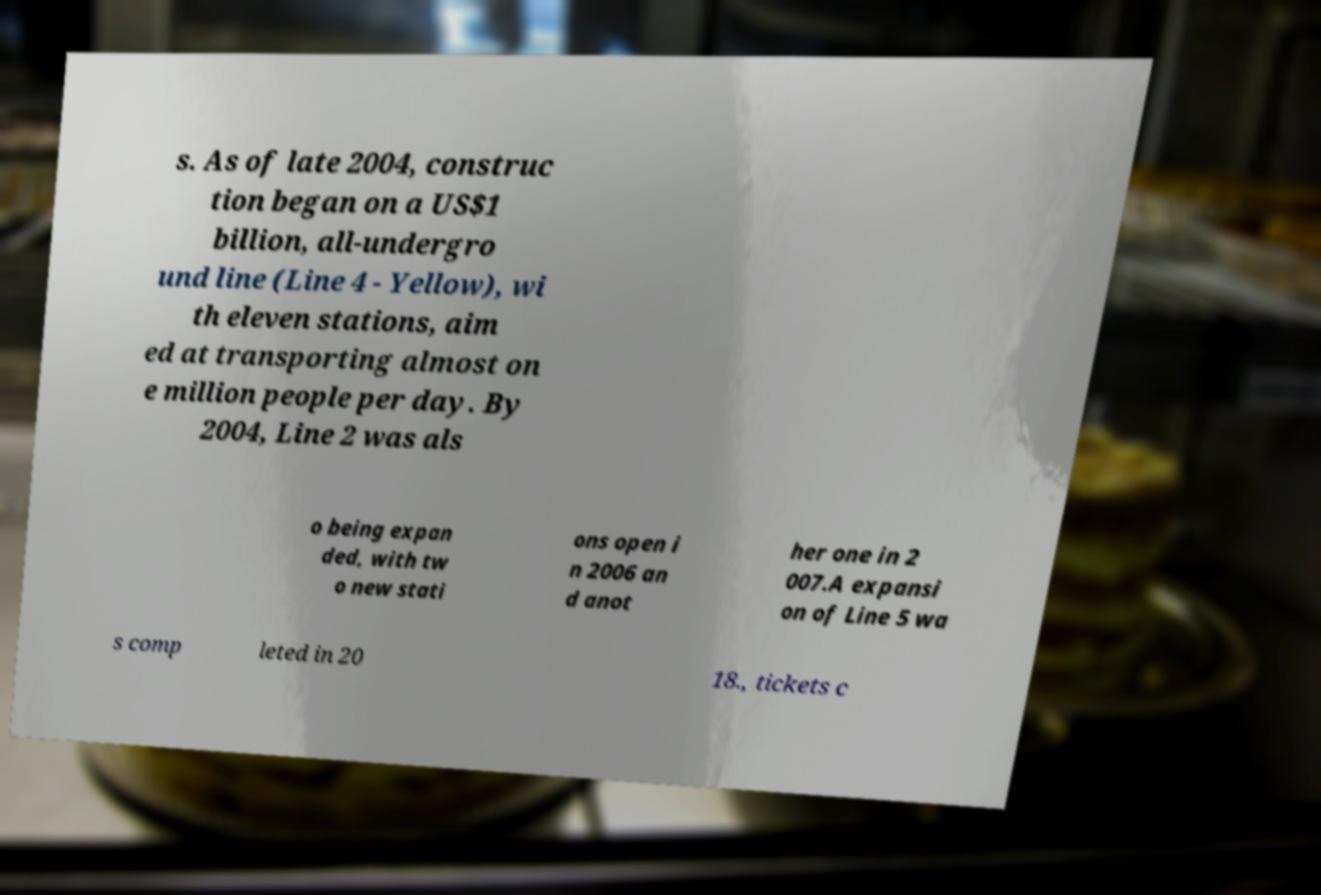Can you accurately transcribe the text from the provided image for me? s. As of late 2004, construc tion began on a US$1 billion, all-undergro und line (Line 4 - Yellow), wi th eleven stations, aim ed at transporting almost on e million people per day. By 2004, Line 2 was als o being expan ded, with tw o new stati ons open i n 2006 an d anot her one in 2 007.A expansi on of Line 5 wa s comp leted in 20 18., tickets c 